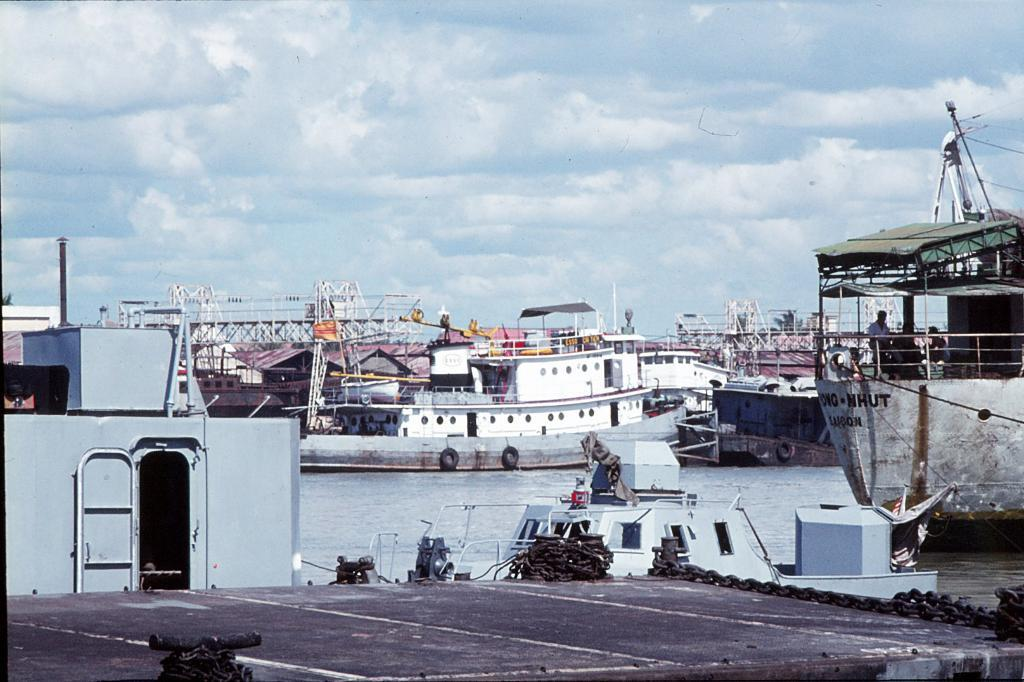What type of objects can be seen in the image? There are metal chains and boats on the water in the image. What are the people in the image doing? Two people are sitting in one of the boats. What can be seen in the background of the image? There are clouds and the sky visible in the background. How many clovers can be seen growing near the boats in the image? There are no clovers present in the image; it features metal chains, boats, and people on the water. What type of store can be seen in the background of the image? There is no store visible in the image; it only shows boats, people, metal chains, clouds, and the sky. 